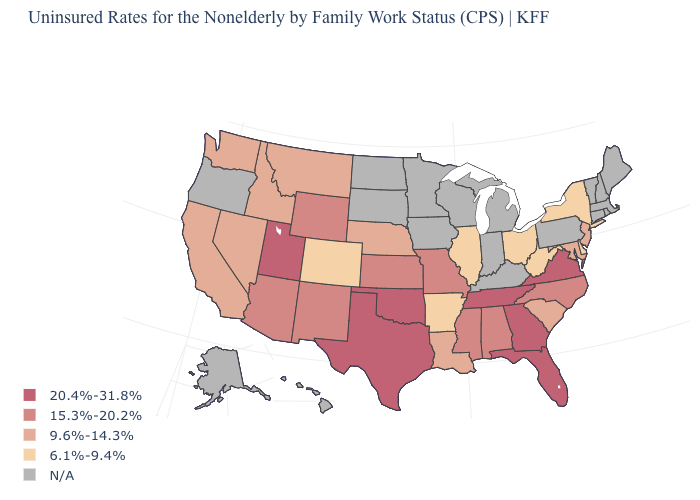Does the first symbol in the legend represent the smallest category?
Answer briefly. No. What is the value of Arkansas?
Answer briefly. 6.1%-9.4%. How many symbols are there in the legend?
Give a very brief answer. 5. Name the states that have a value in the range 6.1%-9.4%?
Give a very brief answer. Arkansas, Colorado, Delaware, Illinois, New York, Ohio, West Virginia. Which states have the lowest value in the Northeast?
Be succinct. New York. What is the highest value in the USA?
Quick response, please. 20.4%-31.8%. What is the highest value in states that border Georgia?
Give a very brief answer. 20.4%-31.8%. Does Montana have the lowest value in the USA?
Concise answer only. No. What is the value of Texas?
Quick response, please. 20.4%-31.8%. Which states have the highest value in the USA?
Quick response, please. Florida, Georgia, Oklahoma, Tennessee, Texas, Utah, Virginia. What is the value of California?
Short answer required. 9.6%-14.3%. Which states have the lowest value in the West?
Write a very short answer. Colorado. Does Texas have the highest value in the USA?
Write a very short answer. Yes. What is the highest value in states that border Texas?
Concise answer only. 20.4%-31.8%. Name the states that have a value in the range 15.3%-20.2%?
Short answer required. Alabama, Arizona, Kansas, Mississippi, Missouri, New Mexico, North Carolina, Wyoming. 